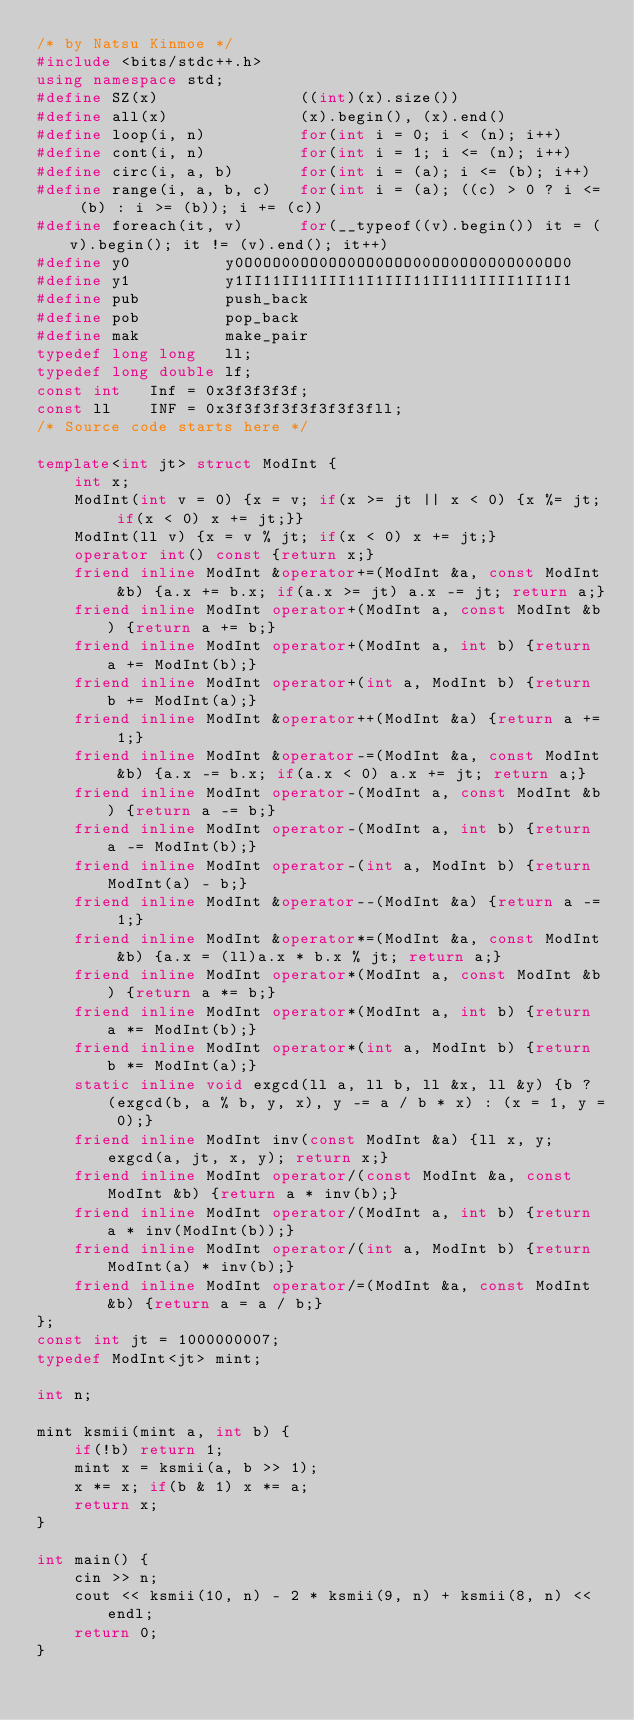<code> <loc_0><loc_0><loc_500><loc_500><_C++_>/* by Natsu Kinmoe */
#include <bits/stdc++.h>
using namespace std;
#define SZ(x)               ((int)(x).size())
#define all(x)              (x).begin(), (x).end()
#define loop(i, n)          for(int i = 0; i < (n); i++)
#define cont(i, n)          for(int i = 1; i <= (n); i++)
#define circ(i, a, b)       for(int i = (a); i <= (b); i++)
#define range(i, a, b, c)   for(int i = (a); ((c) > 0 ? i <= (b) : i >= (b)); i += (c))
#define foreach(it, v)      for(__typeof((v).begin()) it = (v).begin(); it != (v).end(); it++)
#define y0          y0O0OO00OO0OO0OO0OOO00OO0OO0O0O000OO0
#define y1          y1II11II11III11I1III11II111IIII1II1I1
#define pub         push_back
#define pob         pop_back
#define mak         make_pair
typedef long long   ll;
typedef long double lf;
const int   Inf = 0x3f3f3f3f;
const ll    INF = 0x3f3f3f3f3f3f3f3fll;
/* Source code starts here */

template<int jt> struct ModInt {
	int x;
	ModInt(int v = 0) {x = v; if(x >= jt || x < 0) {x %= jt; if(x < 0) x += jt;}}
	ModInt(ll v) {x = v % jt; if(x < 0) x += jt;}
	operator int() const {return x;}
	friend inline ModInt &operator+=(ModInt &a, const ModInt &b) {a.x += b.x; if(a.x >= jt) a.x -= jt; return a;}
	friend inline ModInt operator+(ModInt a, const ModInt &b) {return a += b;}
	friend inline ModInt operator+(ModInt a, int b) {return a += ModInt(b);}
	friend inline ModInt operator+(int a, ModInt b) {return b += ModInt(a);}
	friend inline ModInt &operator++(ModInt &a) {return a += 1;}
	friend inline ModInt &operator-=(ModInt &a, const ModInt &b) {a.x -= b.x; if(a.x < 0) a.x += jt; return a;}
	friend inline ModInt operator-(ModInt a, const ModInt &b) {return a -= b;}
	friend inline ModInt operator-(ModInt a, int b) {return a -= ModInt(b);}
	friend inline ModInt operator-(int a, ModInt b) {return ModInt(a) - b;}
	friend inline ModInt &operator--(ModInt &a) {return a -= 1;}
	friend inline ModInt &operator*=(ModInt &a, const ModInt &b) {a.x = (ll)a.x * b.x % jt; return a;}
	friend inline ModInt operator*(ModInt a, const ModInt &b) {return a *= b;}
	friend inline ModInt operator*(ModInt a, int b) {return a *= ModInt(b);}
	friend inline ModInt operator*(int a, ModInt b) {return b *= ModInt(a);}
	static inline void exgcd(ll a, ll b, ll &x, ll &y) {b ? (exgcd(b, a % b, y, x), y -= a / b * x) : (x = 1, y = 0);}
	friend inline ModInt inv(const ModInt &a) {ll x, y; exgcd(a, jt, x, y); return x;}
	friend inline ModInt operator/(const ModInt &a, const ModInt &b) {return a * inv(b);}
	friend inline ModInt operator/(ModInt a, int b) {return a * inv(ModInt(b));}
	friend inline ModInt operator/(int a, ModInt b) {return ModInt(a) * inv(b);}
	friend inline ModInt operator/=(ModInt &a, const ModInt &b) {return a = a / b;}
};
const int jt = 1000000007;
typedef ModInt<jt> mint;

int n;

mint ksmii(mint a, int b) {
	if(!b) return 1;
	mint x = ksmii(a, b >> 1);
	x *= x; if(b & 1) x *= a;
	return x;
}

int main() {
	cin >> n;
	cout << ksmii(10, n) - 2 * ksmii(9, n) + ksmii(8, n) << endl;
	return 0;
}
</code> 